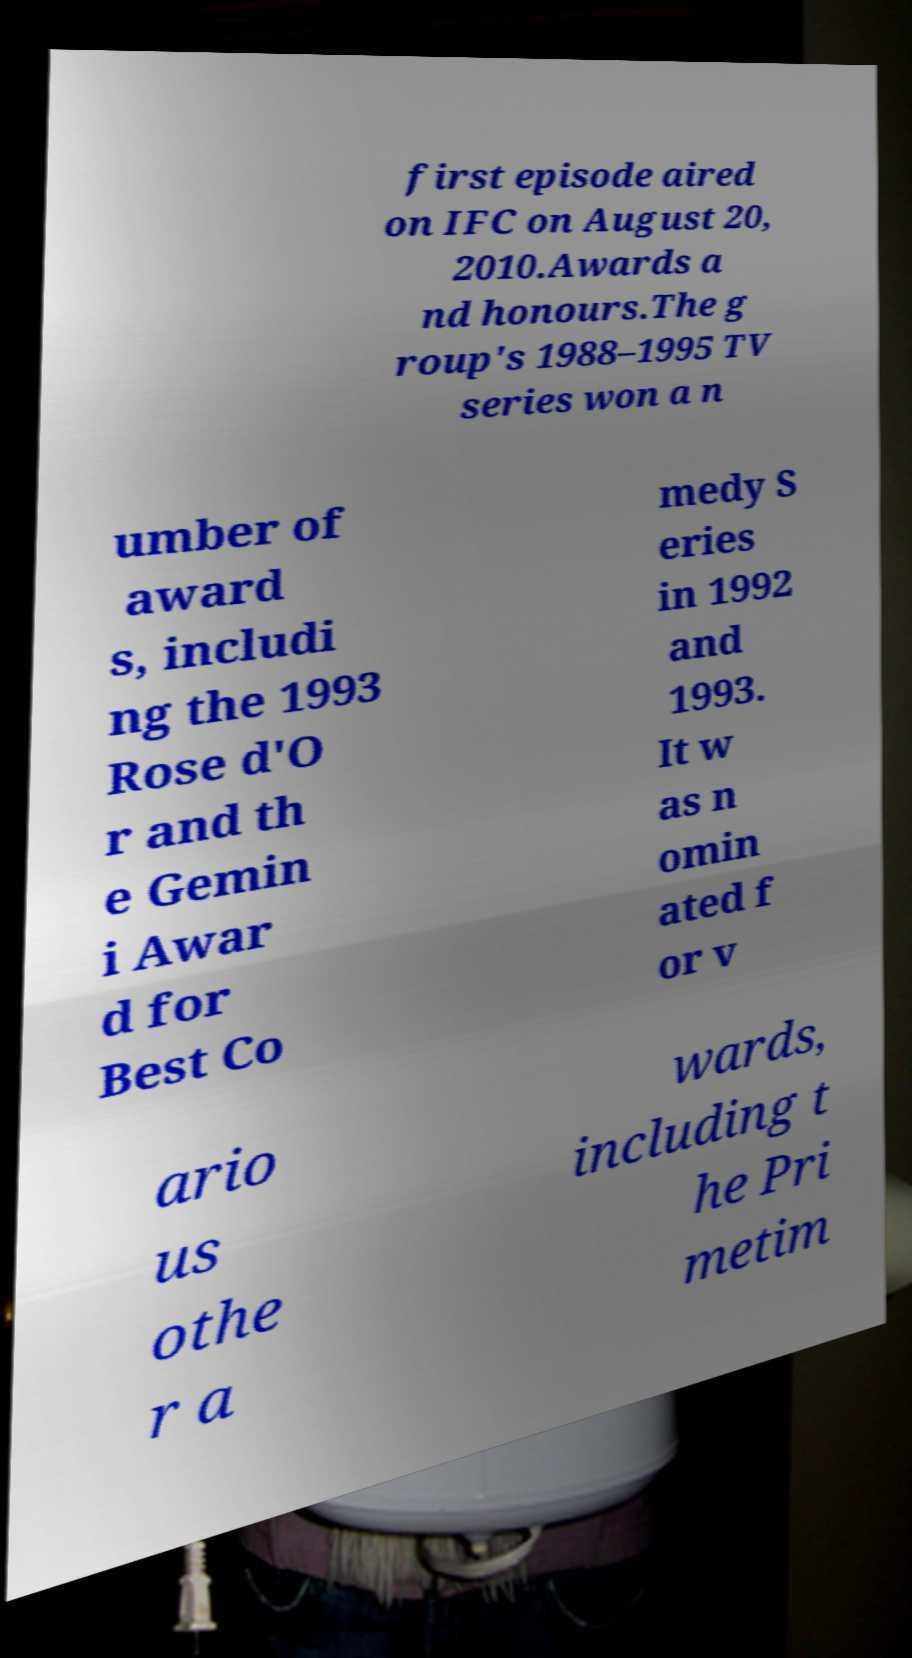Please read and relay the text visible in this image. What does it say? first episode aired on IFC on August 20, 2010.Awards a nd honours.The g roup's 1988–1995 TV series won a n umber of award s, includi ng the 1993 Rose d'O r and th e Gemin i Awar d for Best Co medy S eries in 1992 and 1993. It w as n omin ated f or v ario us othe r a wards, including t he Pri metim 